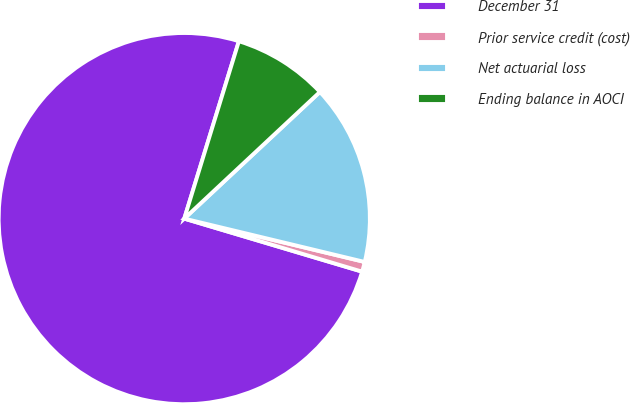Convert chart to OTSL. <chart><loc_0><loc_0><loc_500><loc_500><pie_chart><fcel>December 31<fcel>Prior service credit (cost)<fcel>Net actuarial loss<fcel>Ending balance in AOCI<nl><fcel>75.14%<fcel>0.86%<fcel>15.71%<fcel>8.29%<nl></chart> 